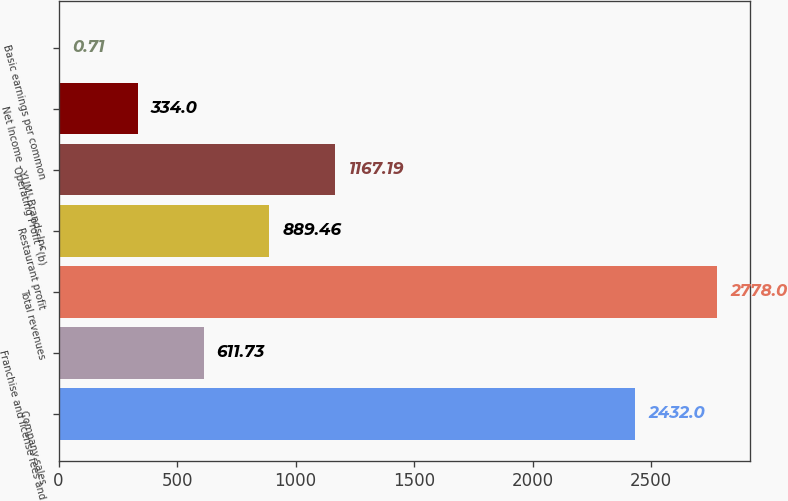Convert chart. <chart><loc_0><loc_0><loc_500><loc_500><bar_chart><fcel>Company sales<fcel>Franchise and license fees and<fcel>Total revenues<fcel>Restaurant profit<fcel>Operating Profit^(b)<fcel>Net Income - YUM! Brands Inc<fcel>Basic earnings per common<nl><fcel>2432<fcel>611.73<fcel>2778<fcel>889.46<fcel>1167.19<fcel>334<fcel>0.71<nl></chart> 